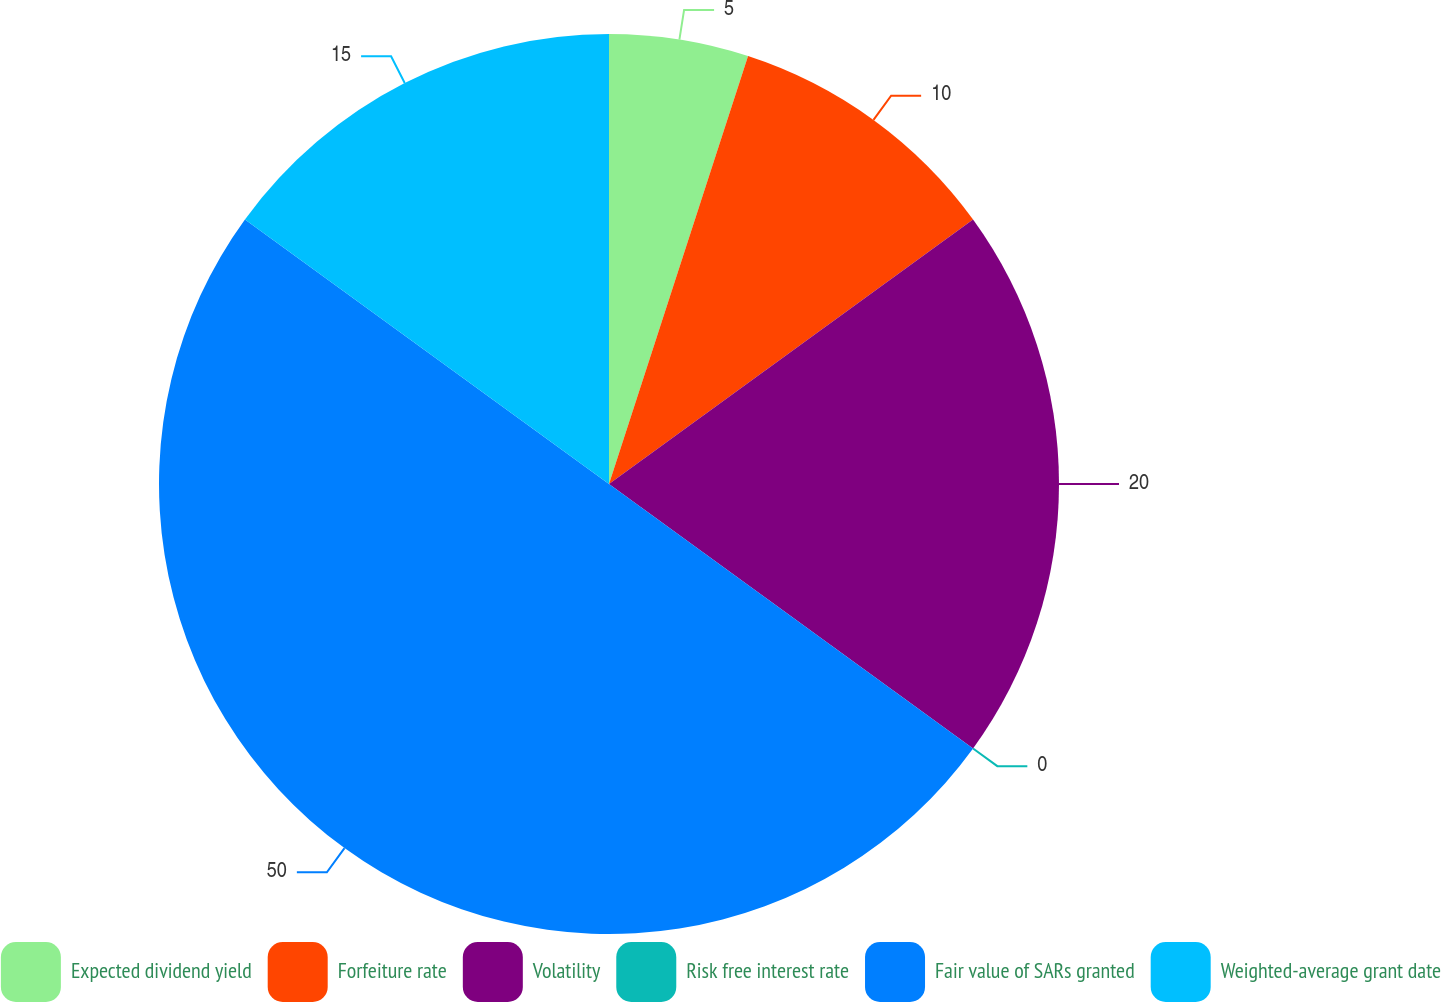<chart> <loc_0><loc_0><loc_500><loc_500><pie_chart><fcel>Expected dividend yield<fcel>Forfeiture rate<fcel>Volatility<fcel>Risk free interest rate<fcel>Fair value of SARs granted<fcel>Weighted-average grant date<nl><fcel>5.0%<fcel>10.0%<fcel>20.0%<fcel>0.0%<fcel>50.0%<fcel>15.0%<nl></chart> 